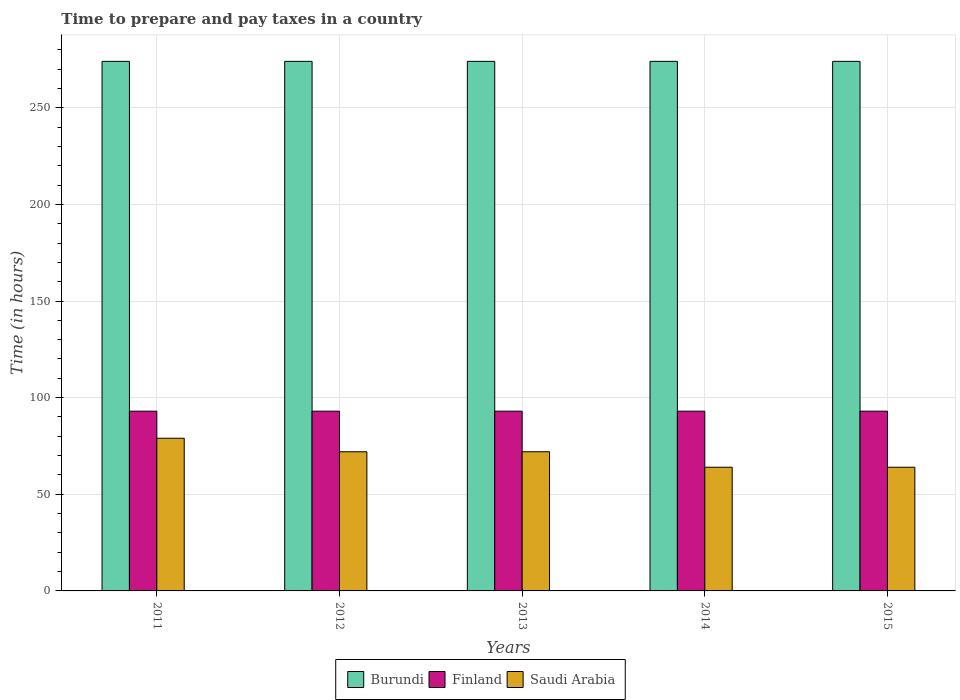How many different coloured bars are there?
Provide a short and direct response. 3. Are the number of bars per tick equal to the number of legend labels?
Make the answer very short. Yes. Are the number of bars on each tick of the X-axis equal?
Your response must be concise. Yes. In how many cases, is the number of bars for a given year not equal to the number of legend labels?
Offer a very short reply. 0. What is the number of hours required to prepare and pay taxes in Finland in 2015?
Make the answer very short. 93. Across all years, what is the maximum number of hours required to prepare and pay taxes in Saudi Arabia?
Provide a succinct answer. 79. Across all years, what is the minimum number of hours required to prepare and pay taxes in Finland?
Offer a terse response. 93. In which year was the number of hours required to prepare and pay taxes in Burundi maximum?
Keep it short and to the point. 2011. What is the total number of hours required to prepare and pay taxes in Burundi in the graph?
Offer a very short reply. 1370. What is the difference between the number of hours required to prepare and pay taxes in Finland in 2011 and the number of hours required to prepare and pay taxes in Burundi in 2013?
Make the answer very short. -181. What is the average number of hours required to prepare and pay taxes in Finland per year?
Your answer should be very brief. 93. In the year 2011, what is the difference between the number of hours required to prepare and pay taxes in Finland and number of hours required to prepare and pay taxes in Saudi Arabia?
Offer a terse response. 14. In how many years, is the number of hours required to prepare and pay taxes in Finland greater than 170 hours?
Your response must be concise. 0. What is the ratio of the number of hours required to prepare and pay taxes in Finland in 2011 to that in 2012?
Your response must be concise. 1. Is the number of hours required to prepare and pay taxes in Saudi Arabia in 2011 less than that in 2012?
Ensure brevity in your answer.  No. Is the difference between the number of hours required to prepare and pay taxes in Finland in 2012 and 2013 greater than the difference between the number of hours required to prepare and pay taxes in Saudi Arabia in 2012 and 2013?
Offer a very short reply. No. In how many years, is the number of hours required to prepare and pay taxes in Burundi greater than the average number of hours required to prepare and pay taxes in Burundi taken over all years?
Provide a succinct answer. 0. What does the 3rd bar from the left in 2013 represents?
Your answer should be compact. Saudi Arabia. Is it the case that in every year, the sum of the number of hours required to prepare and pay taxes in Saudi Arabia and number of hours required to prepare and pay taxes in Burundi is greater than the number of hours required to prepare and pay taxes in Finland?
Keep it short and to the point. Yes. Does the graph contain any zero values?
Your answer should be very brief. No. Does the graph contain grids?
Offer a terse response. Yes. How are the legend labels stacked?
Your answer should be compact. Horizontal. What is the title of the graph?
Provide a succinct answer. Time to prepare and pay taxes in a country. What is the label or title of the Y-axis?
Keep it short and to the point. Time (in hours). What is the Time (in hours) of Burundi in 2011?
Offer a very short reply. 274. What is the Time (in hours) in Finland in 2011?
Provide a succinct answer. 93. What is the Time (in hours) in Saudi Arabia in 2011?
Offer a very short reply. 79. What is the Time (in hours) of Burundi in 2012?
Your answer should be very brief. 274. What is the Time (in hours) in Finland in 2012?
Offer a terse response. 93. What is the Time (in hours) of Saudi Arabia in 2012?
Keep it short and to the point. 72. What is the Time (in hours) in Burundi in 2013?
Offer a terse response. 274. What is the Time (in hours) of Finland in 2013?
Offer a terse response. 93. What is the Time (in hours) of Saudi Arabia in 2013?
Your answer should be compact. 72. What is the Time (in hours) in Burundi in 2014?
Ensure brevity in your answer.  274. What is the Time (in hours) in Finland in 2014?
Give a very brief answer. 93. What is the Time (in hours) in Burundi in 2015?
Give a very brief answer. 274. What is the Time (in hours) of Finland in 2015?
Make the answer very short. 93. What is the Time (in hours) in Saudi Arabia in 2015?
Keep it short and to the point. 64. Across all years, what is the maximum Time (in hours) of Burundi?
Offer a terse response. 274. Across all years, what is the maximum Time (in hours) of Finland?
Offer a very short reply. 93. Across all years, what is the maximum Time (in hours) of Saudi Arabia?
Your answer should be very brief. 79. Across all years, what is the minimum Time (in hours) of Burundi?
Your answer should be very brief. 274. Across all years, what is the minimum Time (in hours) of Finland?
Your answer should be very brief. 93. What is the total Time (in hours) of Burundi in the graph?
Provide a succinct answer. 1370. What is the total Time (in hours) in Finland in the graph?
Provide a succinct answer. 465. What is the total Time (in hours) in Saudi Arabia in the graph?
Give a very brief answer. 351. What is the difference between the Time (in hours) in Burundi in 2011 and that in 2012?
Provide a succinct answer. 0. What is the difference between the Time (in hours) in Saudi Arabia in 2011 and that in 2012?
Make the answer very short. 7. What is the difference between the Time (in hours) in Burundi in 2011 and that in 2013?
Your answer should be compact. 0. What is the difference between the Time (in hours) of Burundi in 2012 and that in 2013?
Keep it short and to the point. 0. What is the difference between the Time (in hours) in Finland in 2012 and that in 2014?
Your answer should be very brief. 0. What is the difference between the Time (in hours) in Saudi Arabia in 2012 and that in 2014?
Your answer should be very brief. 8. What is the difference between the Time (in hours) in Burundi in 2012 and that in 2015?
Provide a succinct answer. 0. What is the difference between the Time (in hours) in Finland in 2012 and that in 2015?
Offer a very short reply. 0. What is the difference between the Time (in hours) of Saudi Arabia in 2012 and that in 2015?
Your response must be concise. 8. What is the difference between the Time (in hours) in Finland in 2013 and that in 2014?
Your response must be concise. 0. What is the difference between the Time (in hours) of Saudi Arabia in 2013 and that in 2015?
Your answer should be compact. 8. What is the difference between the Time (in hours) in Saudi Arabia in 2014 and that in 2015?
Your answer should be compact. 0. What is the difference between the Time (in hours) of Burundi in 2011 and the Time (in hours) of Finland in 2012?
Offer a very short reply. 181. What is the difference between the Time (in hours) in Burundi in 2011 and the Time (in hours) in Saudi Arabia in 2012?
Your answer should be compact. 202. What is the difference between the Time (in hours) in Finland in 2011 and the Time (in hours) in Saudi Arabia in 2012?
Your response must be concise. 21. What is the difference between the Time (in hours) in Burundi in 2011 and the Time (in hours) in Finland in 2013?
Your answer should be compact. 181. What is the difference between the Time (in hours) in Burundi in 2011 and the Time (in hours) in Saudi Arabia in 2013?
Your answer should be compact. 202. What is the difference between the Time (in hours) in Finland in 2011 and the Time (in hours) in Saudi Arabia in 2013?
Provide a short and direct response. 21. What is the difference between the Time (in hours) in Burundi in 2011 and the Time (in hours) in Finland in 2014?
Offer a terse response. 181. What is the difference between the Time (in hours) in Burundi in 2011 and the Time (in hours) in Saudi Arabia in 2014?
Give a very brief answer. 210. What is the difference between the Time (in hours) of Finland in 2011 and the Time (in hours) of Saudi Arabia in 2014?
Give a very brief answer. 29. What is the difference between the Time (in hours) in Burundi in 2011 and the Time (in hours) in Finland in 2015?
Offer a very short reply. 181. What is the difference between the Time (in hours) of Burundi in 2011 and the Time (in hours) of Saudi Arabia in 2015?
Provide a succinct answer. 210. What is the difference between the Time (in hours) in Finland in 2011 and the Time (in hours) in Saudi Arabia in 2015?
Ensure brevity in your answer.  29. What is the difference between the Time (in hours) in Burundi in 2012 and the Time (in hours) in Finland in 2013?
Your answer should be very brief. 181. What is the difference between the Time (in hours) of Burundi in 2012 and the Time (in hours) of Saudi Arabia in 2013?
Your answer should be very brief. 202. What is the difference between the Time (in hours) in Burundi in 2012 and the Time (in hours) in Finland in 2014?
Keep it short and to the point. 181. What is the difference between the Time (in hours) in Burundi in 2012 and the Time (in hours) in Saudi Arabia in 2014?
Give a very brief answer. 210. What is the difference between the Time (in hours) in Burundi in 2012 and the Time (in hours) in Finland in 2015?
Give a very brief answer. 181. What is the difference between the Time (in hours) in Burundi in 2012 and the Time (in hours) in Saudi Arabia in 2015?
Offer a terse response. 210. What is the difference between the Time (in hours) in Finland in 2012 and the Time (in hours) in Saudi Arabia in 2015?
Ensure brevity in your answer.  29. What is the difference between the Time (in hours) in Burundi in 2013 and the Time (in hours) in Finland in 2014?
Offer a terse response. 181. What is the difference between the Time (in hours) of Burundi in 2013 and the Time (in hours) of Saudi Arabia in 2014?
Make the answer very short. 210. What is the difference between the Time (in hours) in Finland in 2013 and the Time (in hours) in Saudi Arabia in 2014?
Make the answer very short. 29. What is the difference between the Time (in hours) of Burundi in 2013 and the Time (in hours) of Finland in 2015?
Give a very brief answer. 181. What is the difference between the Time (in hours) in Burundi in 2013 and the Time (in hours) in Saudi Arabia in 2015?
Your answer should be very brief. 210. What is the difference between the Time (in hours) of Finland in 2013 and the Time (in hours) of Saudi Arabia in 2015?
Your response must be concise. 29. What is the difference between the Time (in hours) of Burundi in 2014 and the Time (in hours) of Finland in 2015?
Ensure brevity in your answer.  181. What is the difference between the Time (in hours) in Burundi in 2014 and the Time (in hours) in Saudi Arabia in 2015?
Give a very brief answer. 210. What is the difference between the Time (in hours) of Finland in 2014 and the Time (in hours) of Saudi Arabia in 2015?
Your response must be concise. 29. What is the average Time (in hours) of Burundi per year?
Provide a succinct answer. 274. What is the average Time (in hours) in Finland per year?
Offer a very short reply. 93. What is the average Time (in hours) in Saudi Arabia per year?
Your answer should be compact. 70.2. In the year 2011, what is the difference between the Time (in hours) in Burundi and Time (in hours) in Finland?
Offer a very short reply. 181. In the year 2011, what is the difference between the Time (in hours) of Burundi and Time (in hours) of Saudi Arabia?
Offer a very short reply. 195. In the year 2011, what is the difference between the Time (in hours) of Finland and Time (in hours) of Saudi Arabia?
Your answer should be very brief. 14. In the year 2012, what is the difference between the Time (in hours) in Burundi and Time (in hours) in Finland?
Offer a terse response. 181. In the year 2012, what is the difference between the Time (in hours) of Burundi and Time (in hours) of Saudi Arabia?
Offer a very short reply. 202. In the year 2013, what is the difference between the Time (in hours) in Burundi and Time (in hours) in Finland?
Your answer should be very brief. 181. In the year 2013, what is the difference between the Time (in hours) in Burundi and Time (in hours) in Saudi Arabia?
Offer a very short reply. 202. In the year 2014, what is the difference between the Time (in hours) in Burundi and Time (in hours) in Finland?
Ensure brevity in your answer.  181. In the year 2014, what is the difference between the Time (in hours) of Burundi and Time (in hours) of Saudi Arabia?
Provide a short and direct response. 210. In the year 2014, what is the difference between the Time (in hours) of Finland and Time (in hours) of Saudi Arabia?
Ensure brevity in your answer.  29. In the year 2015, what is the difference between the Time (in hours) of Burundi and Time (in hours) of Finland?
Provide a short and direct response. 181. In the year 2015, what is the difference between the Time (in hours) in Burundi and Time (in hours) in Saudi Arabia?
Provide a succinct answer. 210. In the year 2015, what is the difference between the Time (in hours) in Finland and Time (in hours) in Saudi Arabia?
Your answer should be compact. 29. What is the ratio of the Time (in hours) of Burundi in 2011 to that in 2012?
Provide a succinct answer. 1. What is the ratio of the Time (in hours) in Finland in 2011 to that in 2012?
Give a very brief answer. 1. What is the ratio of the Time (in hours) of Saudi Arabia in 2011 to that in 2012?
Make the answer very short. 1.1. What is the ratio of the Time (in hours) of Burundi in 2011 to that in 2013?
Provide a short and direct response. 1. What is the ratio of the Time (in hours) of Finland in 2011 to that in 2013?
Ensure brevity in your answer.  1. What is the ratio of the Time (in hours) of Saudi Arabia in 2011 to that in 2013?
Provide a short and direct response. 1.1. What is the ratio of the Time (in hours) of Burundi in 2011 to that in 2014?
Offer a very short reply. 1. What is the ratio of the Time (in hours) in Finland in 2011 to that in 2014?
Offer a very short reply. 1. What is the ratio of the Time (in hours) of Saudi Arabia in 2011 to that in 2014?
Make the answer very short. 1.23. What is the ratio of the Time (in hours) of Burundi in 2011 to that in 2015?
Ensure brevity in your answer.  1. What is the ratio of the Time (in hours) of Finland in 2011 to that in 2015?
Provide a succinct answer. 1. What is the ratio of the Time (in hours) of Saudi Arabia in 2011 to that in 2015?
Ensure brevity in your answer.  1.23. What is the ratio of the Time (in hours) in Burundi in 2012 to that in 2013?
Keep it short and to the point. 1. What is the ratio of the Time (in hours) of Finland in 2012 to that in 2013?
Make the answer very short. 1. What is the ratio of the Time (in hours) in Saudi Arabia in 2012 to that in 2014?
Offer a very short reply. 1.12. What is the ratio of the Time (in hours) in Burundi in 2012 to that in 2015?
Your answer should be very brief. 1. What is the ratio of the Time (in hours) in Saudi Arabia in 2012 to that in 2015?
Provide a succinct answer. 1.12. What is the ratio of the Time (in hours) of Burundi in 2013 to that in 2014?
Provide a succinct answer. 1. What is the ratio of the Time (in hours) in Finland in 2013 to that in 2014?
Ensure brevity in your answer.  1. What is the ratio of the Time (in hours) of Saudi Arabia in 2013 to that in 2014?
Offer a very short reply. 1.12. What is the ratio of the Time (in hours) in Burundi in 2013 to that in 2015?
Offer a terse response. 1. What is the ratio of the Time (in hours) in Finland in 2013 to that in 2015?
Your response must be concise. 1. What is the ratio of the Time (in hours) in Saudi Arabia in 2013 to that in 2015?
Offer a terse response. 1.12. What is the difference between the highest and the second highest Time (in hours) of Burundi?
Provide a succinct answer. 0. What is the difference between the highest and the second highest Time (in hours) in Finland?
Your answer should be compact. 0. What is the difference between the highest and the second highest Time (in hours) of Saudi Arabia?
Provide a succinct answer. 7. What is the difference between the highest and the lowest Time (in hours) in Burundi?
Your answer should be very brief. 0. What is the difference between the highest and the lowest Time (in hours) in Saudi Arabia?
Make the answer very short. 15. 